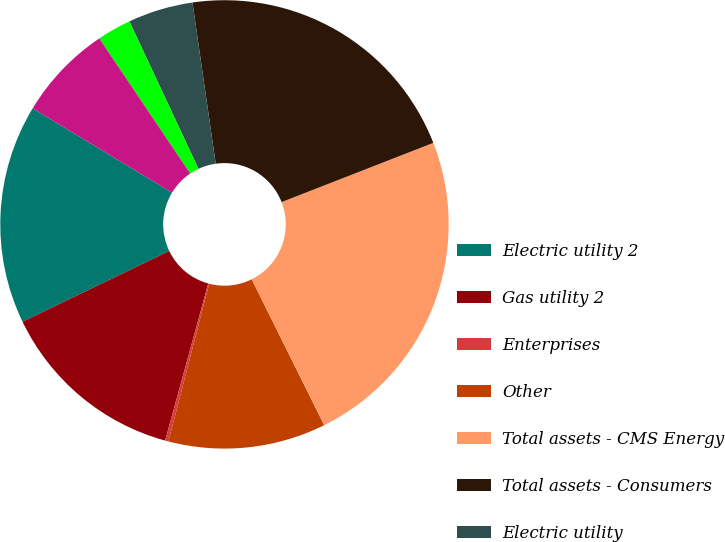Convert chart to OTSL. <chart><loc_0><loc_0><loc_500><loc_500><pie_chart><fcel>Electric utility 2<fcel>Gas utility 2<fcel>Enterprises<fcel>Other<fcel>Total assets - CMS Energy<fcel>Total assets - Consumers<fcel>Electric utility<fcel>Gas utility<fcel>Total capital expenditures -<nl><fcel>15.81%<fcel>13.59%<fcel>0.24%<fcel>11.36%<fcel>23.59%<fcel>21.36%<fcel>4.69%<fcel>2.46%<fcel>6.91%<nl></chart> 